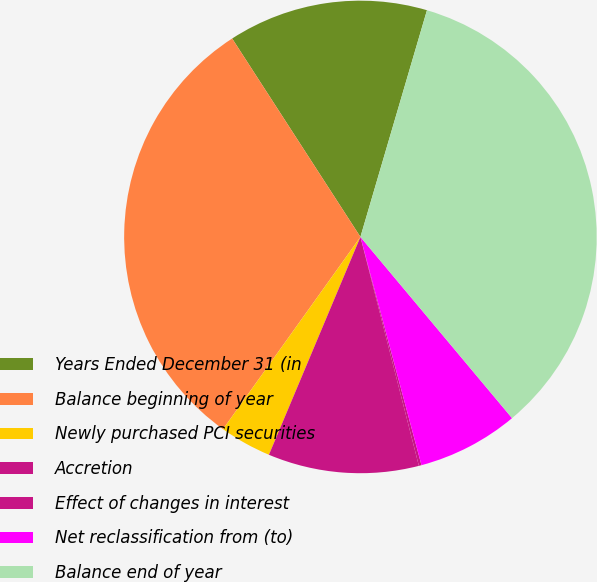<chart> <loc_0><loc_0><loc_500><loc_500><pie_chart><fcel>Years Ended December 31 (in<fcel>Balance beginning of year<fcel>Newly purchased PCI securities<fcel>Accretion<fcel>Effect of changes in interest<fcel>Net reclassification from (to)<fcel>Balance end of year<nl><fcel>13.68%<fcel>30.99%<fcel>3.55%<fcel>10.31%<fcel>0.18%<fcel>6.93%<fcel>34.37%<nl></chart> 